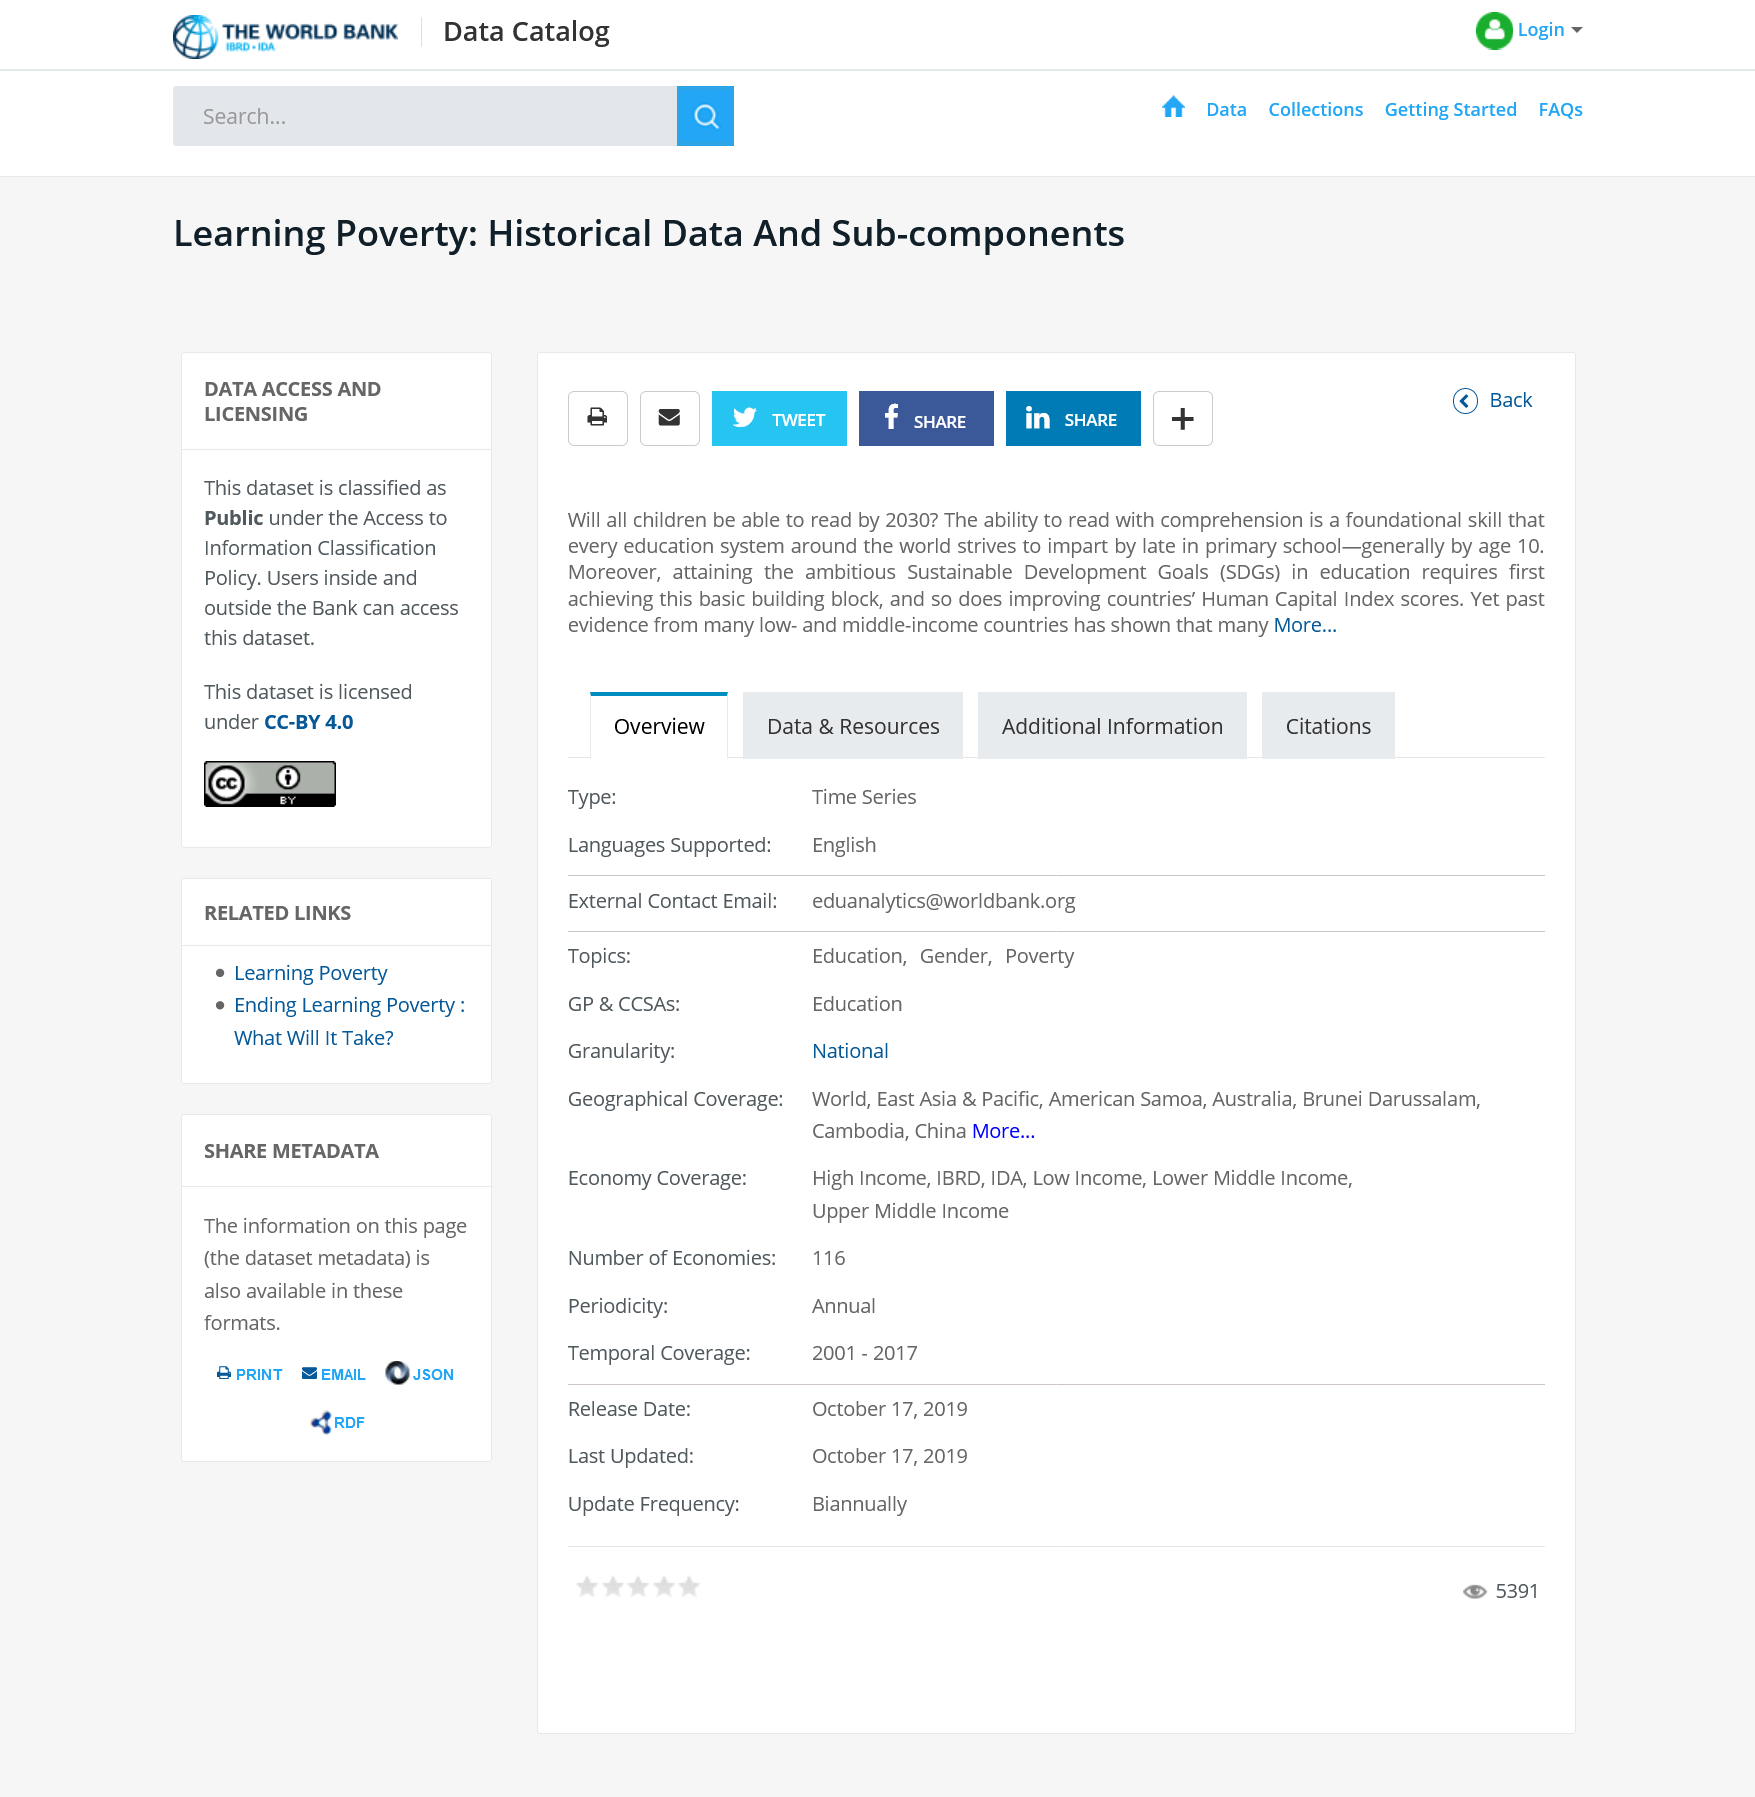Indicate a few pertinent items in this graphic. It is expected that children at the primary school level have the ability to read with comprehension by the age of 10. The Sustainable Development Goals (SDGs) are a set of global objectives aimed at ending poverty, protecting the planet, and promoting prosperity for all. It is a widely acknowledged fact that every education system aims to impart the foundational skill of reading comprehension by the end of primary school, as this skill is considered to be the cornerstone of academic success. 